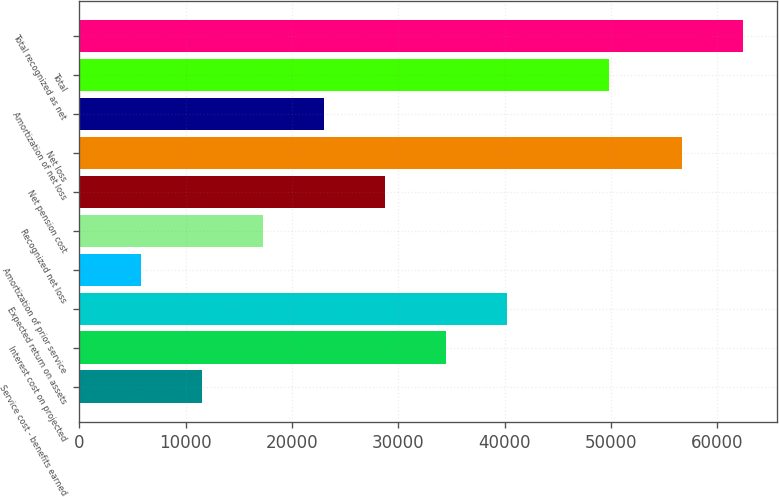<chart> <loc_0><loc_0><loc_500><loc_500><bar_chart><fcel>Service cost - benefits earned<fcel>Interest cost on projected<fcel>Expected return on assets<fcel>Amortization of prior service<fcel>Recognized net loss<fcel>Net pension cost<fcel>Net loss<fcel>Amortization of net loss<fcel>Total<fcel>Total recognized as net<nl><fcel>11525.4<fcel>34516.2<fcel>40263.9<fcel>5777.7<fcel>17273.1<fcel>28768.5<fcel>56714<fcel>23020.8<fcel>49845<fcel>62461.7<nl></chart> 